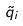Convert formula to latex. <formula><loc_0><loc_0><loc_500><loc_500>\tilde { q } _ { i }</formula> 